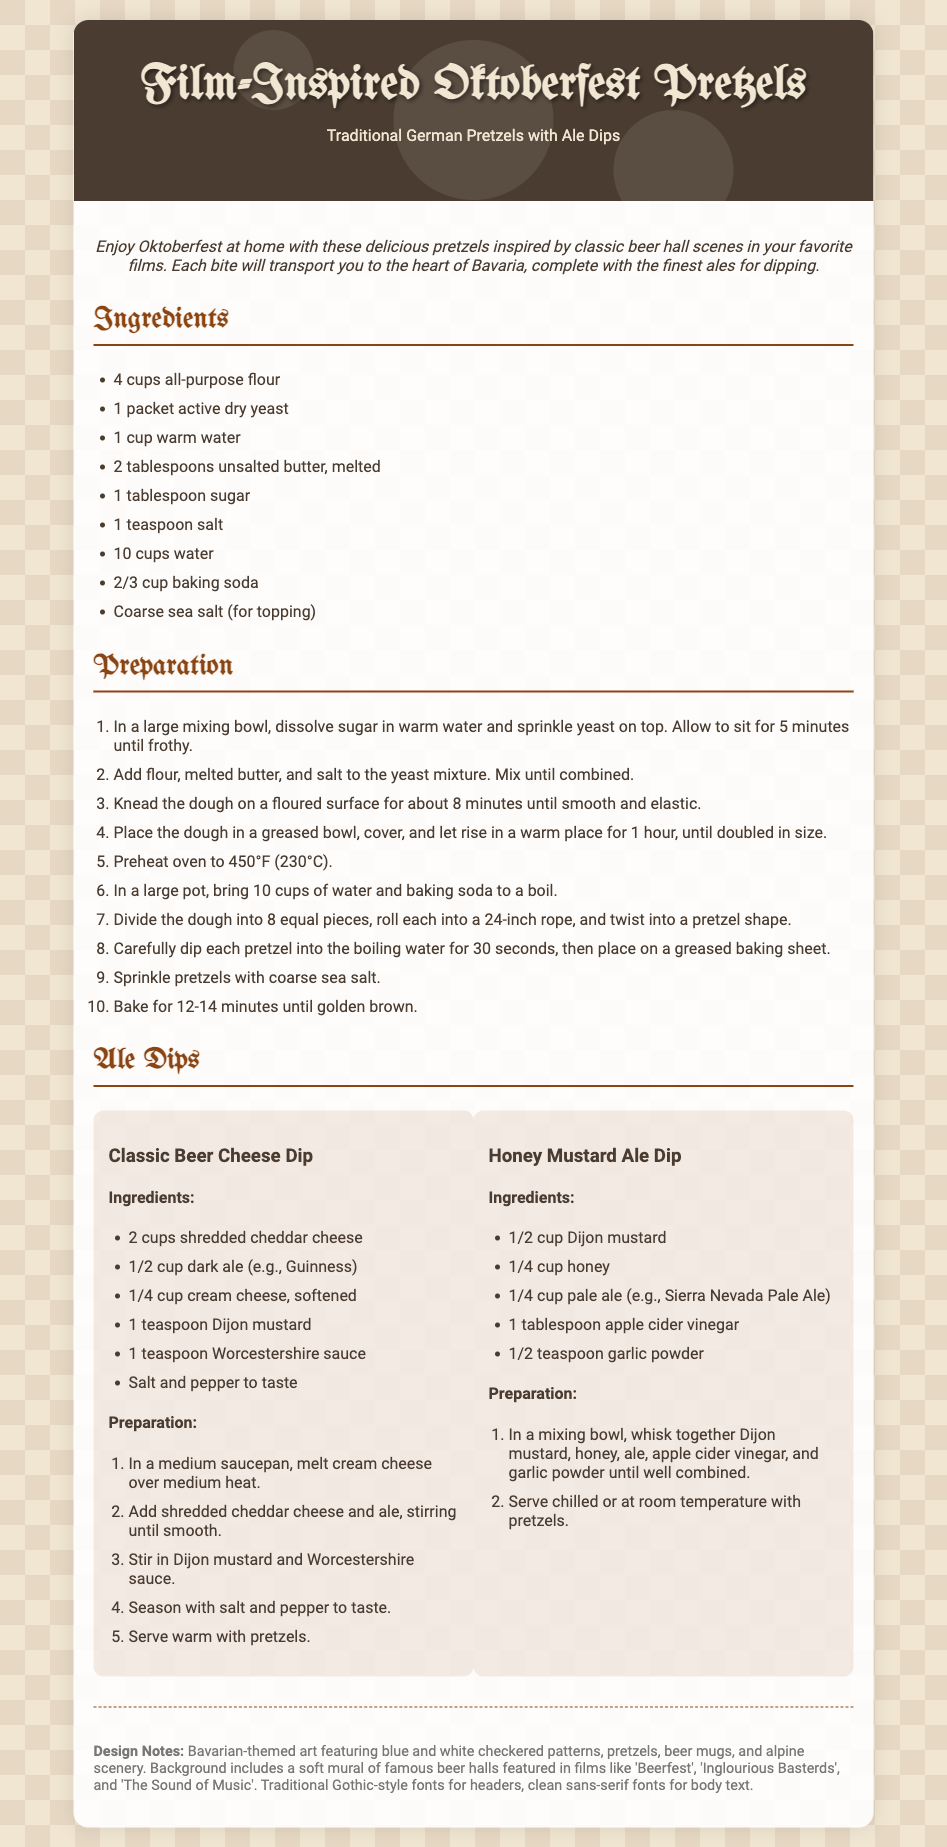What is the main dish featured in the recipe card? The title indicates that the recipe card features Oktoberfest Pretzels.
Answer: Oktoberfest Pretzels How many cups of all-purpose flour are needed? The ingredients list specifies the amount of flour required for the recipe.
Answer: 4 cups What temperature should the oven be preheated to? The preparation section states the temperature for baking the pretzels.
Answer: 450°F What type of beer is used in the Classic Beer Cheese Dip? The ingredients for the Classic Beer Cheese Dip specifies the type of ale to be used.
Answer: Dark ale What is the total number of ingredients listed for the Honey Mustard Ale Dip? The ingredients list for the Honey Mustard Ale Dip includes each item that needs to be combined.
Answer: 5 What film is specifically mentioned in the design notes? The design notes mention which movies inspired the mural featuring famous beer halls.
Answer: Beerfest What ingredient is common between both ale dips? Analyzing both ale dips leads to identifying a shared ingredient.
Answer: Ale Which font family is used for the recipe card headers? The style section of the document indicates the fonts chosen for headers.
Answer: UnifrakturMaguntia 